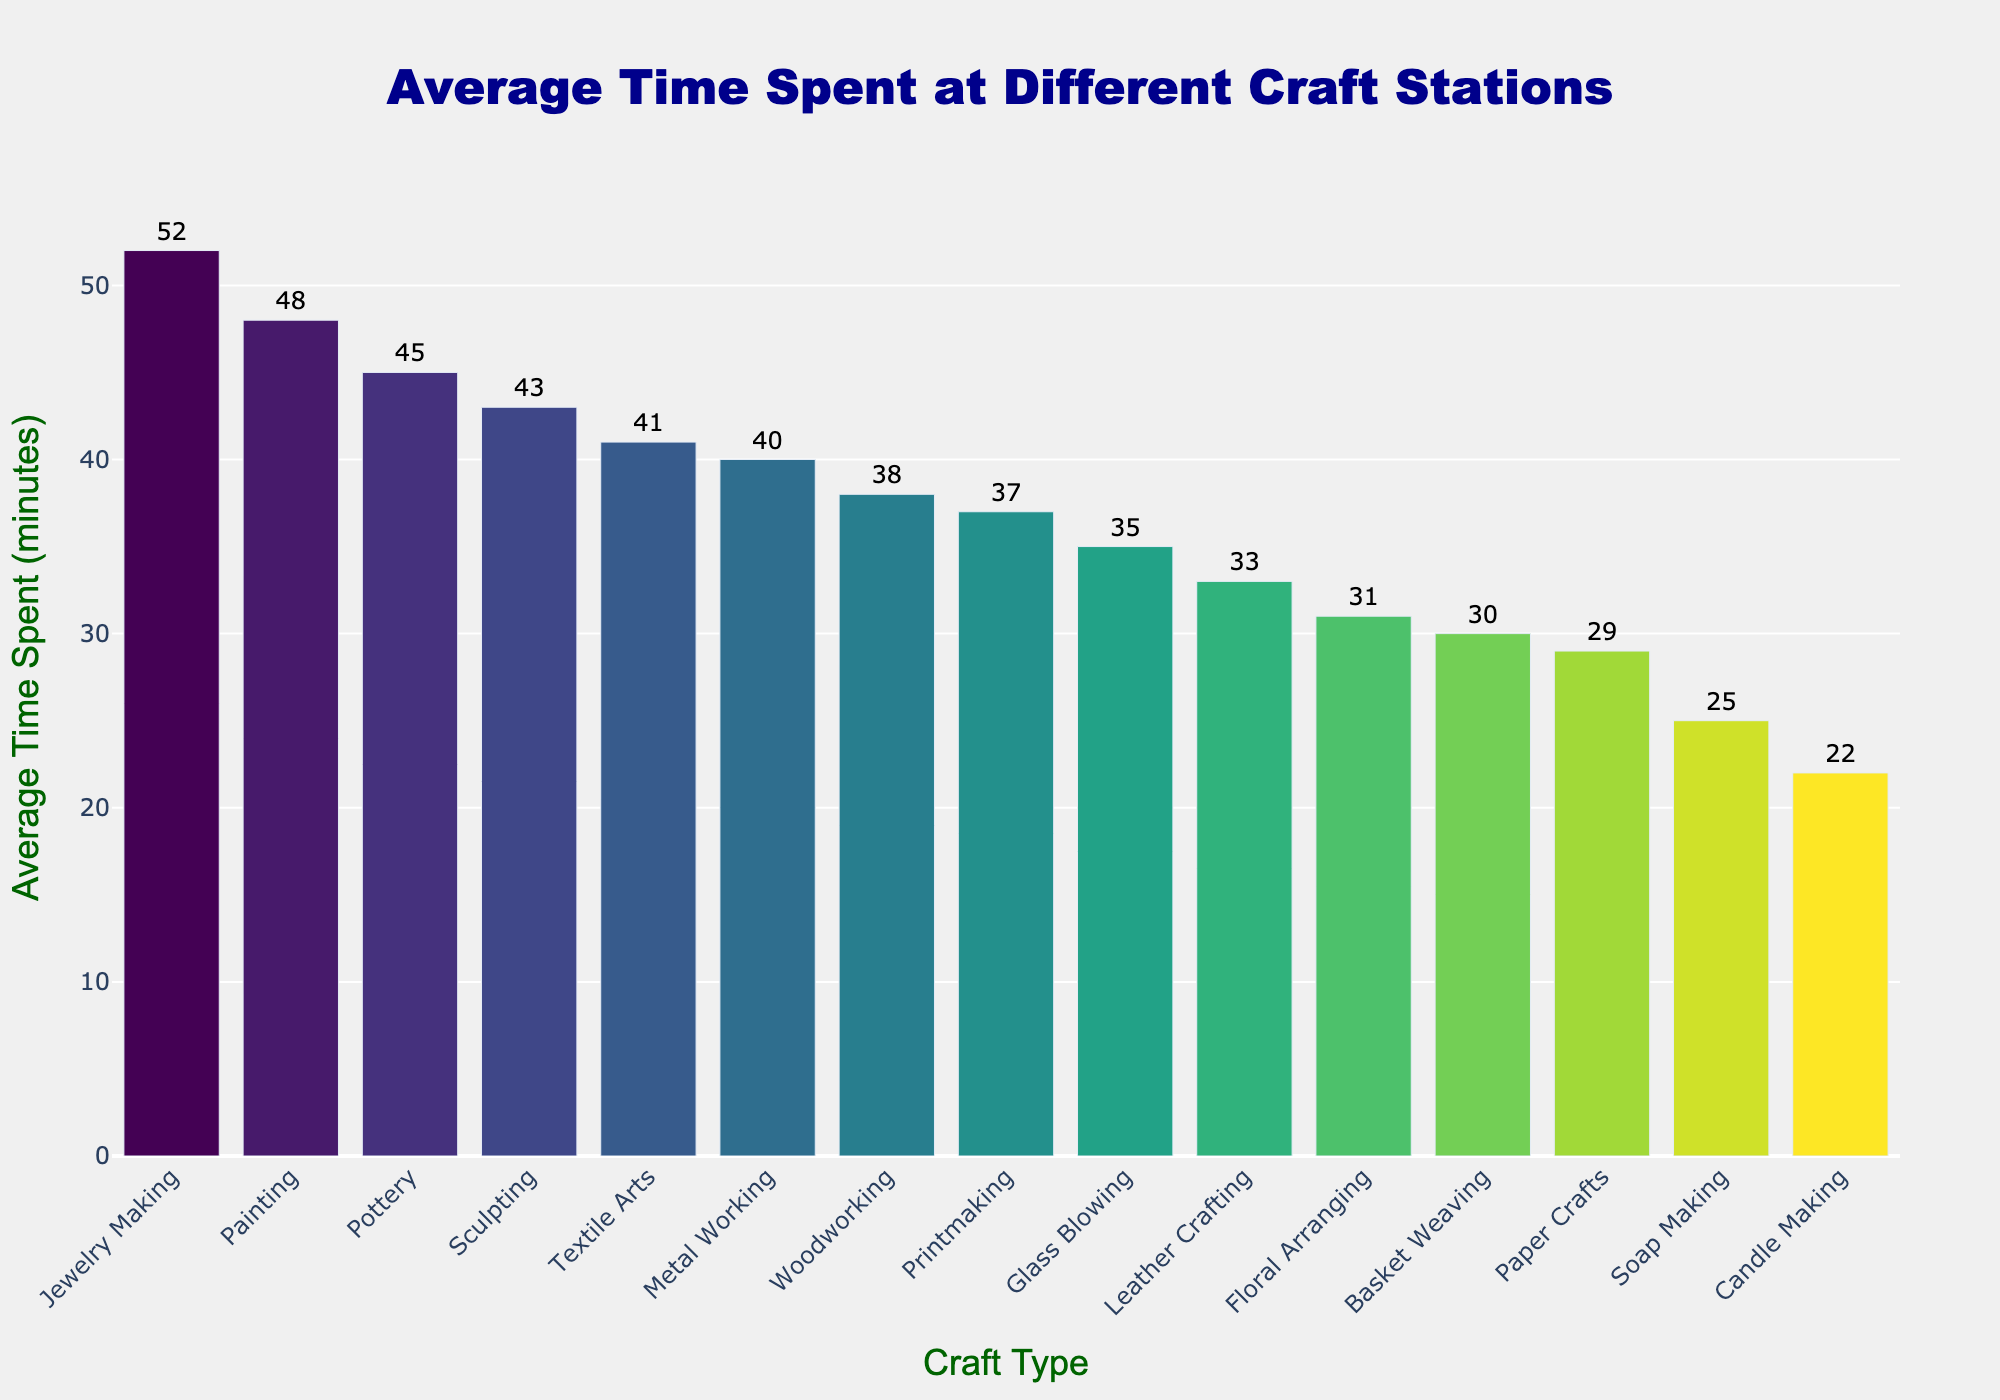What's the craft type with the highest average time spent? Look for the tallest bar in the chart. Jewelry Making has the highest average time spent of 52 minutes.
Answer: Jewelry Making What is the total time spent on Pottery and Painting combined? Find the average time spent on Pottery (45 minutes) and Painting (48 minutes), then sum them up: 45 + 48 = 93 minutes.
Answer: 93 minutes Which craft type spends less time on average: Candle Making or Soap Making? Compare the heights of the bars for Candle Making (22 minutes) and Soap Making (25 minutes). Candle Making has a shorter bar, indicating less time spent on average.
Answer: Candle Making How much more time is spent on Metal Working compared to Leather Crafting? Subtract the average time spent on Leather Crafting (33 minutes) from Metal Working (40 minutes). 40 - 33 = 7 minutes.
Answer: 7 minutes Which craft types have an average time spent greater than 40 minutes? Identify all bars with average times higher than 40 minutes. These are: Pottery (45), Jewelry Making (52), Textile Arts (41), Painting (48), Sculpting (43).
Answer: Pottery, Jewelry Making, Textile Arts, Painting, Sculpting What is the average time spent on Paper Crafts? Refer to the bar height for Paper Crafts. The average time spent is 29 minutes.
Answer: 29 minutes Rank the top three craft types with the highest average time spent. Sort the bars in descending order based on average time spent. The top three are: 1) Jewelry Making (52 minutes), 2) Painting (48 minutes), 3) Pottery (45 minutes).
Answer: 1) Jewelry Making 2) Painting 3) Pottery What is the difference in average time spent between the longest and shortest craft types? Identify the longest bar (Jewelry Making, 52 minutes) and the shortest bar (Candle Making, 22 minutes). Subtract the shortest from the longest: 52 - 22 = 30 minutes.
Answer: 30 minutes How much more time is spent on average on Woodworking compared to Candle Making? Subtract the average time spent on Candle Making (22 minutes) from Woodworking (38 minutes). 38 - 22 = 16 minutes.
Answer: 16 minutes Compare the average time spent on Textile Arts and Printmaking. Which one is greater and by how much? Compare the bar heights: Textile Arts (41 minutes) and Printmaking (37 minutes). The difference is 41 - 37 = 4 minutes, and Textile Arts has the greater time.
Answer: Textile Arts by 4 minutes 